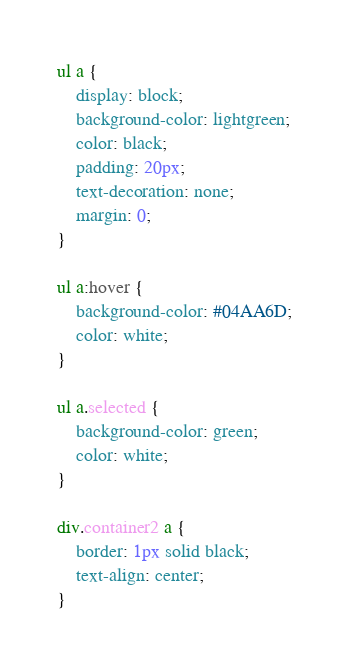Convert code to text. <code><loc_0><loc_0><loc_500><loc_500><_CSS_>ul a {
    display: block;
    background-color: lightgreen;
    color: black;
    padding: 20px;
    text-decoration: none;
    margin: 0;
}

ul a:hover {
    background-color: #04AA6D;
    color: white;
}

ul a.selected {
    background-color: green;
    color: white;
}

div.container2 a {
    border: 1px solid black;
    text-align: center;
}</code> 